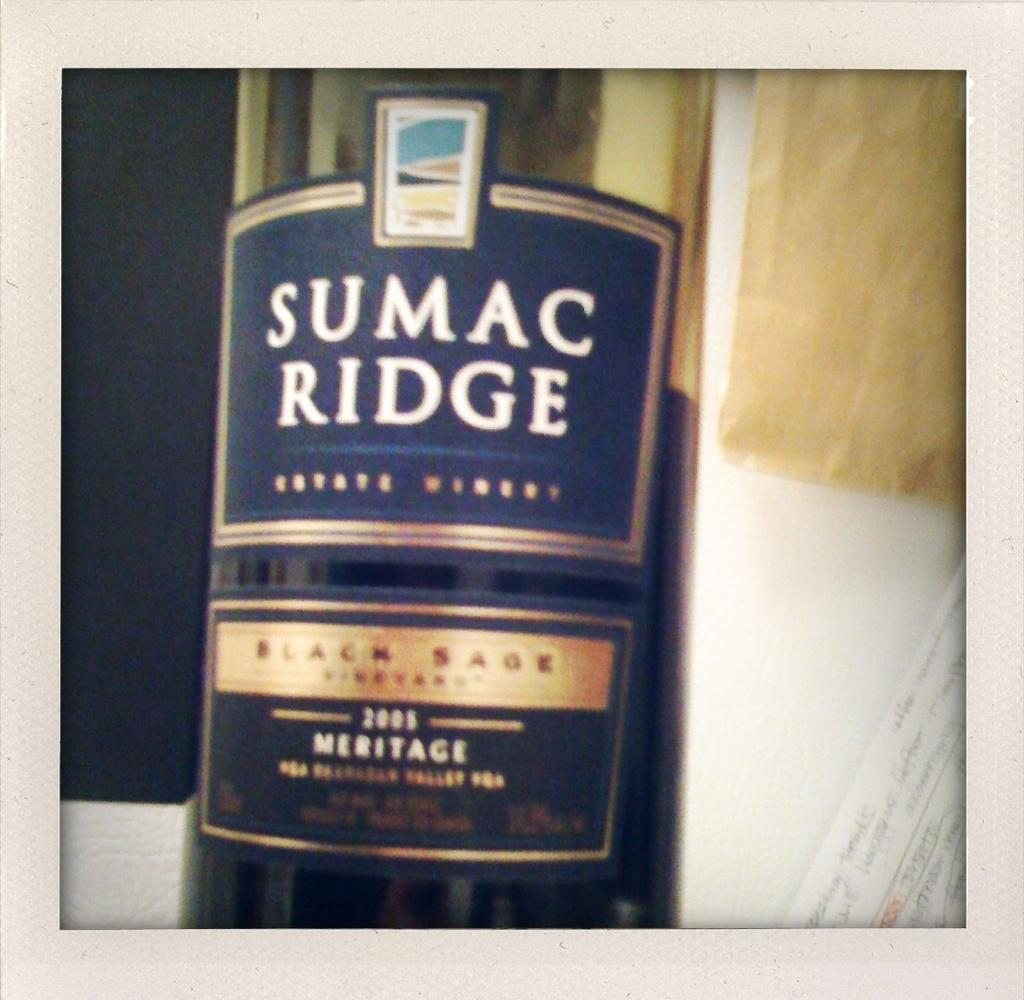What is the main object visible in the image? There is a wine bottle in the image. What type of butter is being used to support the wine bottle in the image? There is no butter present in the image, nor is it being used to support the wine bottle. 